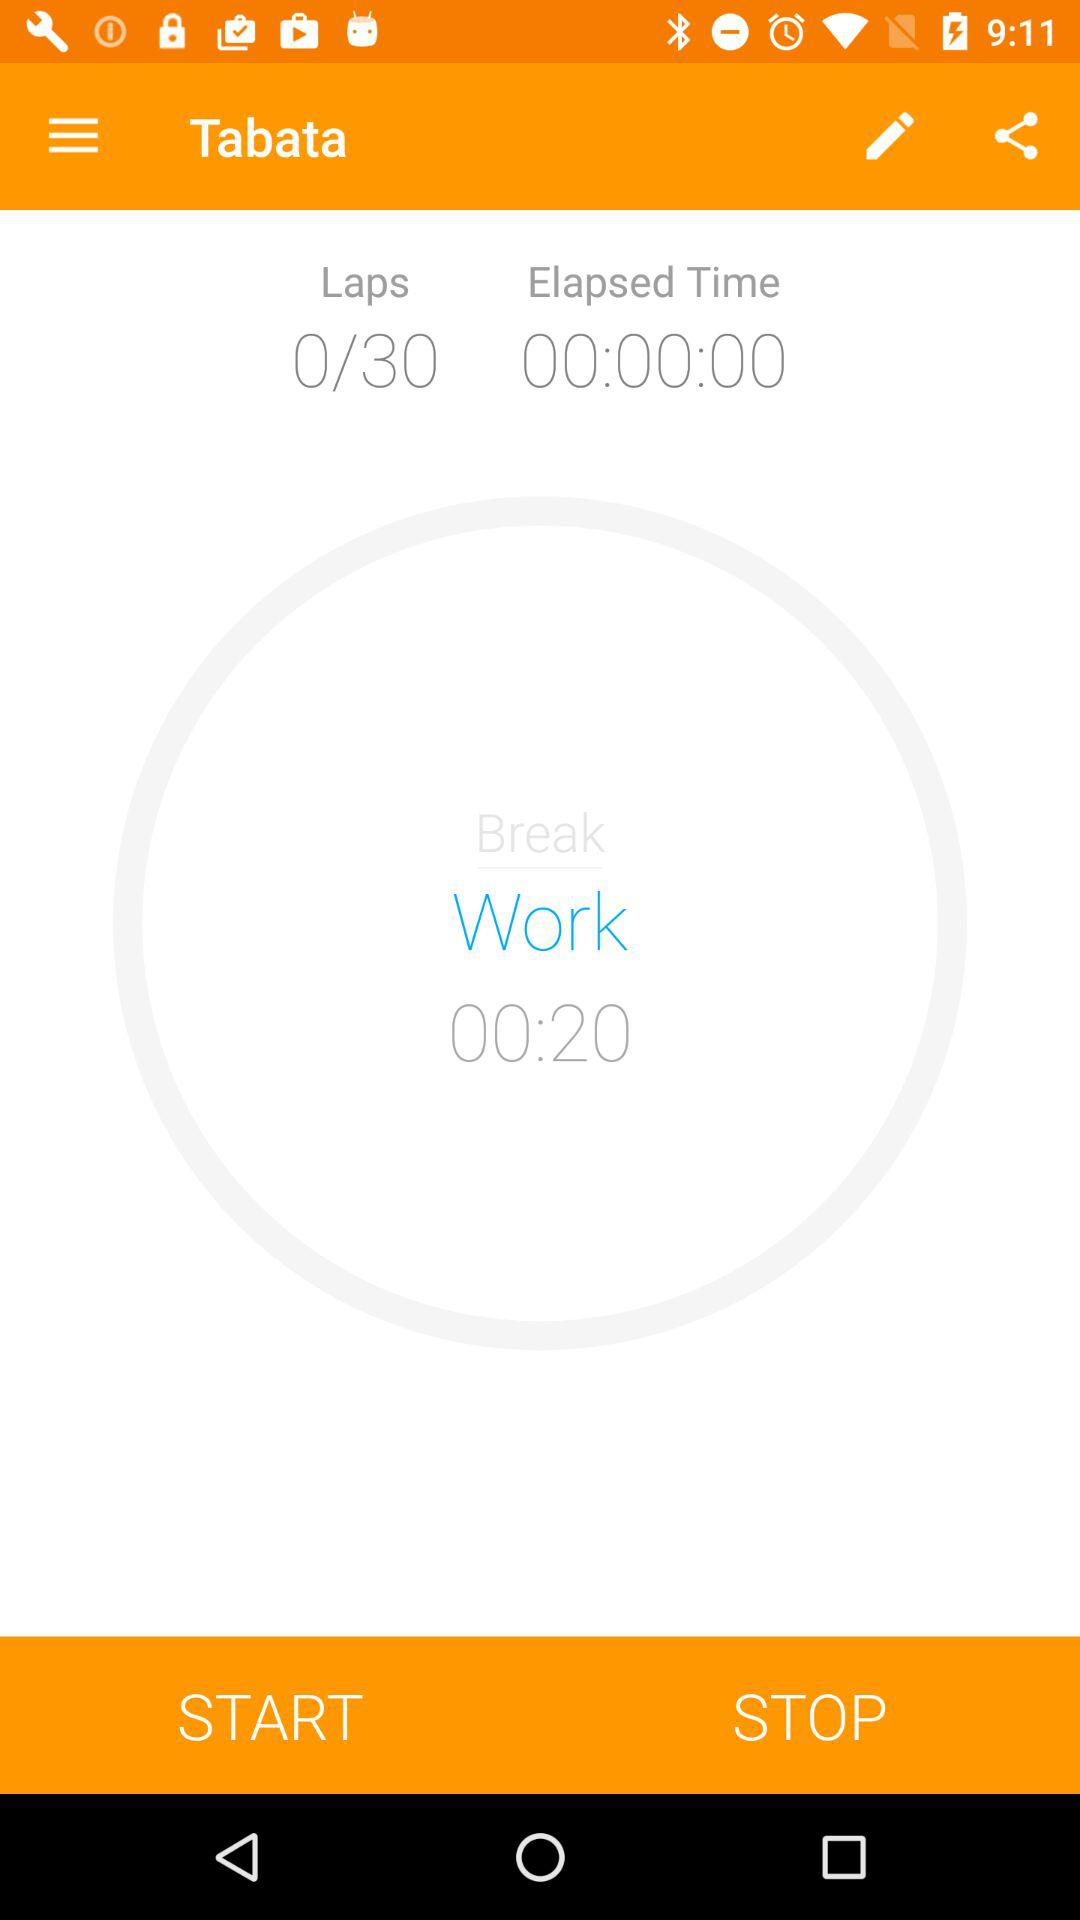What is the work time? The work time is 00:20. 